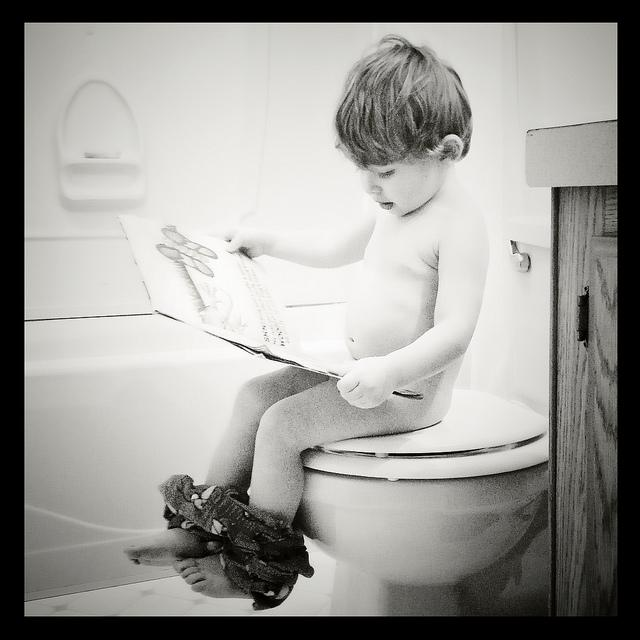What does the child do here? potty 